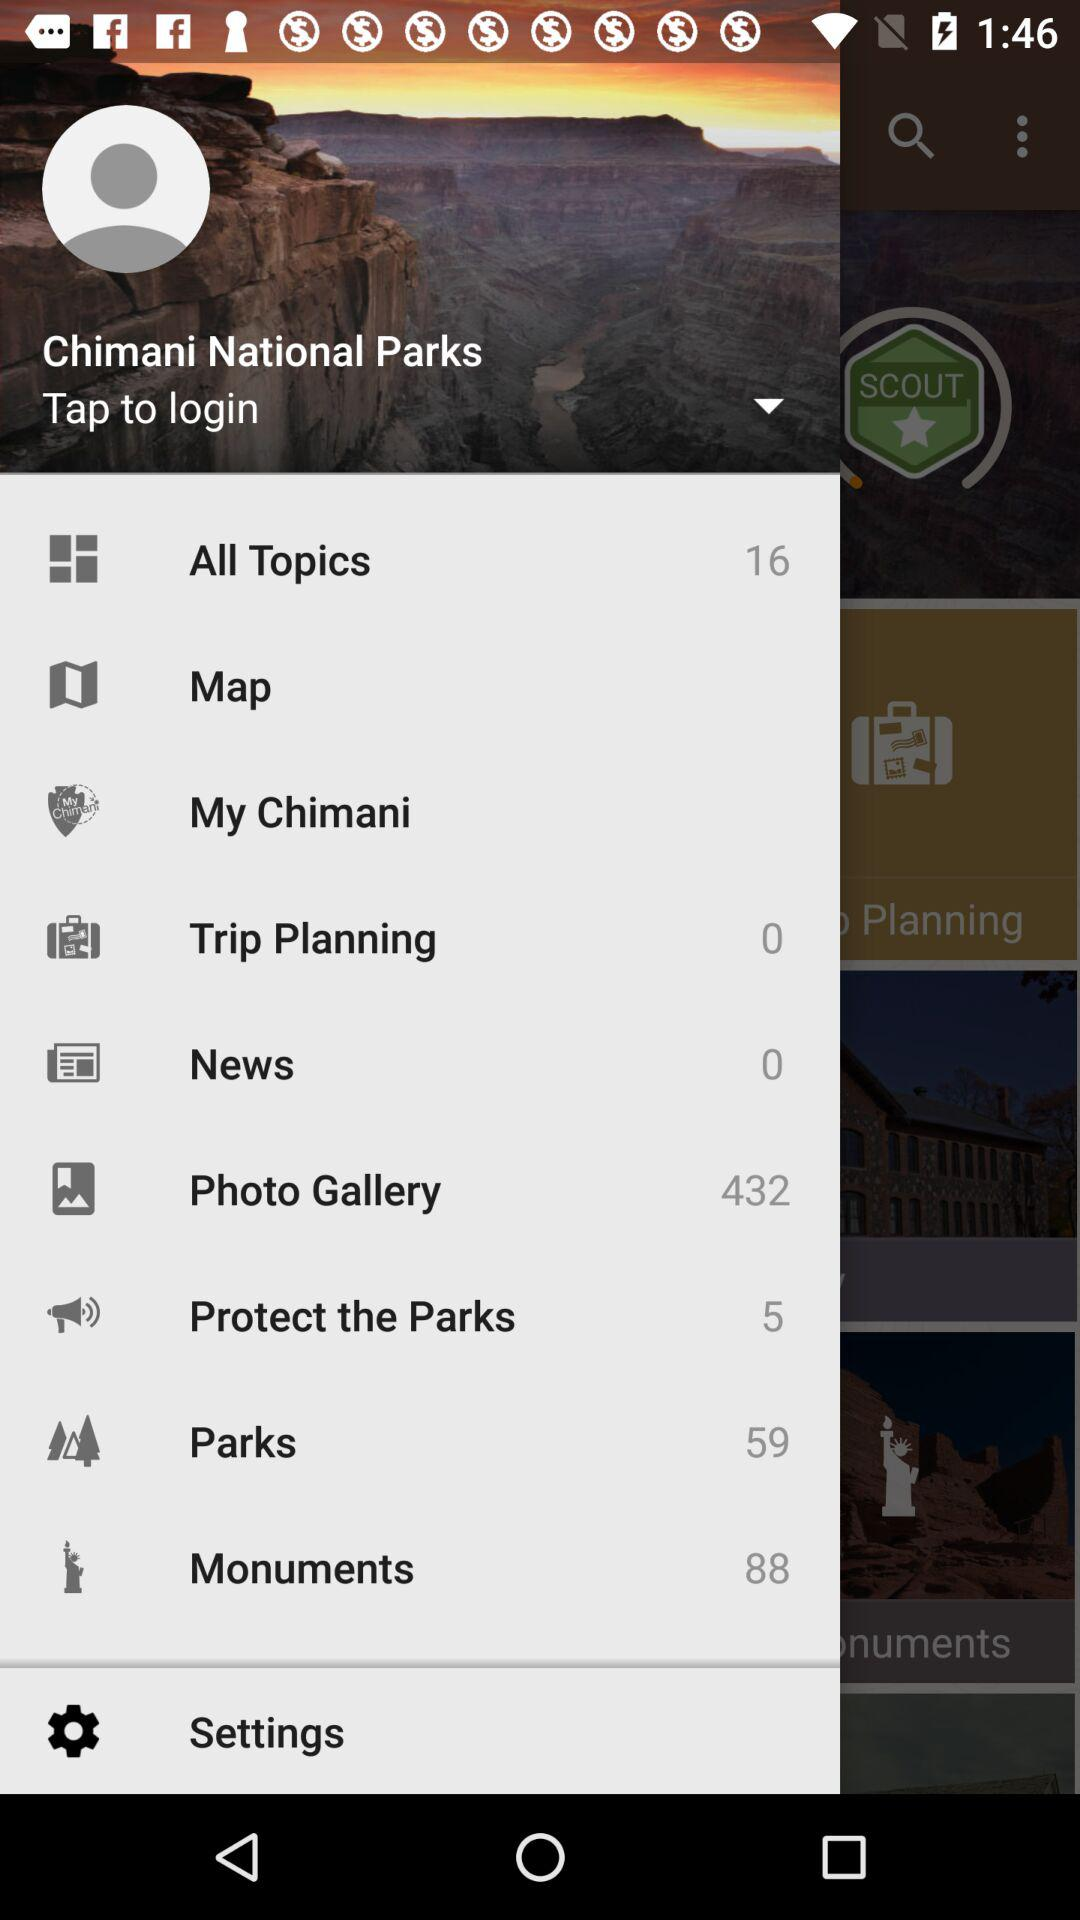What is the number of photos in the "Photo Gallery"? The number of photos is 432. 